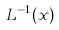Convert formula to latex. <formula><loc_0><loc_0><loc_500><loc_500>L ^ { - 1 } ( x )</formula> 